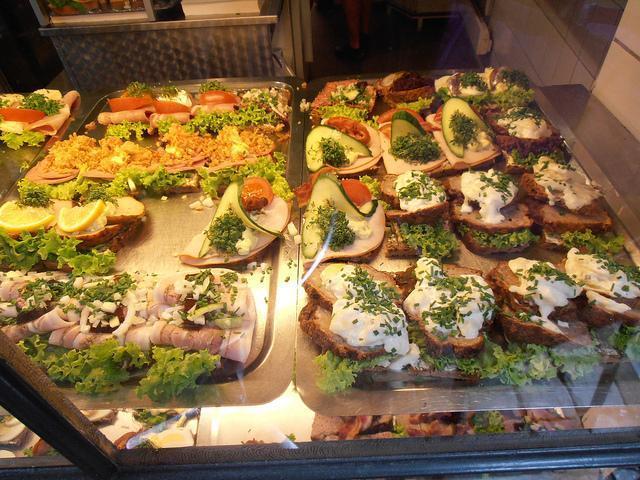How many sandwiches are in the picture?
Give a very brief answer. 15. How many black dogs are there?
Give a very brief answer. 0. 